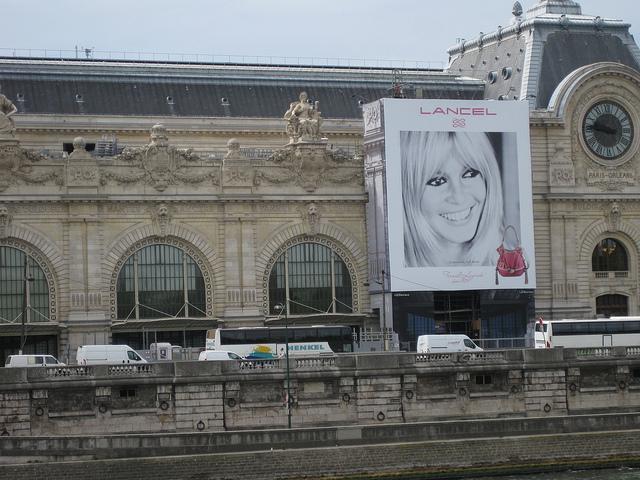How many vehicles are in the photo?
Give a very brief answer. 5. How many buses can you see?
Give a very brief answer. 2. 